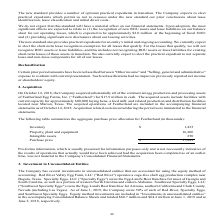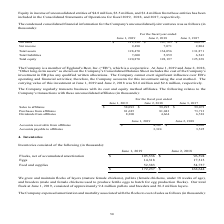According to Cal Maine Foods's financial document, What is the net sales in 2019? According to the financial document, 112,396 (in thousands). The relevant text states: "une 1, 2019 June 2, 2018 June 3, 2017 Net sales $ 112,396 $ 107,705 $ 86,072 Net income 9,490 7,071 2,804 Total assets 128,470 134,056 131,871 Total liabilit..." Also, can you calculate: What is the increase in net sales from 2018 to 2019? Based on the calculation: 112,396 - 107,705, the result is 4691 (in thousands). This is based on the information: "9 June 2, 2018 June 3, 2017 Net sales $ 112,396 $ 107,705 $ 86,072 Net income 9,490 7,071 2,804 Total assets 128,470 134,056 131,871 Total liabilities 7,600 une 1, 2019 June 2, 2018 June 3, 2017 Net s..." The key data points involved are: 107,705, 112,396. Also, can you calculate: What is the average total assets in 3 years? To answer this question, I need to perform calculations using the financial data. The calculation is: (128,470 + 134,056 + 131,871) / 3, which equals 131465.67 (in thousands). This is based on the information: "86,072 Net income 9,490 7,071 2,804 Total assets 128,470 134,056 131,871 Total liabilities 7,600 5,859 6,543 Total equity 120,870 128,197 125,328 me 9,490 7,071 2,804 Total assets 128,470 134,056 131,..." The key data points involved are: 128,470, 131,871, 134,056. Also, can you calculate: What is the Return on Assets in 2019? Based on the calculation: 9,490 / 128,470, the result is 7.39 (percentage). This is based on the information: "Net sales $ 112,396 $ 107,705 $ 86,072 Net income 9,490 7,071 2,804 Total assets 128,470 134,056 131,871 Total liabilities 7,600 5,859 6,543 Total equity 1 86,072 Net income 9,490 7,071 2,804 Total as..." The key data points involved are: 128,470, 9,490. Also, Which method is used by the company to account for investments? investment using the cost method. The document states: "ivities; therefore, the Company accounts for this investment using the cost method. The carrying value of this investment at June 1, 2019 and June 2, ..." Also, What percentage each of Red River, Specialty Eggs, and Southwest Specialty Eggs is owned by the company? According to the financial document, 50%. The relevant text states: "g Las Vegas). As of June 1, 2019, the Company owns 50% of each of Red River, Specialty Eggs, and Southwest Specialty Eggs. Equity method investments are in..." 